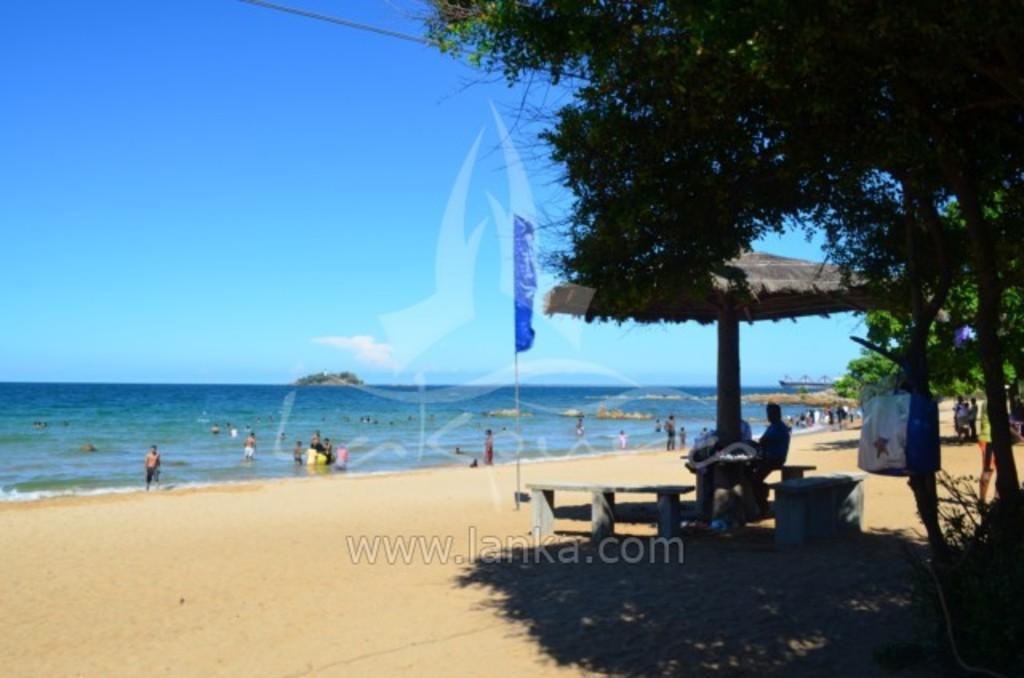Could you give a brief overview of what you see in this image? In this image in the center there are empty benches and there are persons sitting and there is a tent. On the right side there are trees and there is a bag hanging on a tree. In the background there are persons in the water and there is an ocean and there is a flag. 